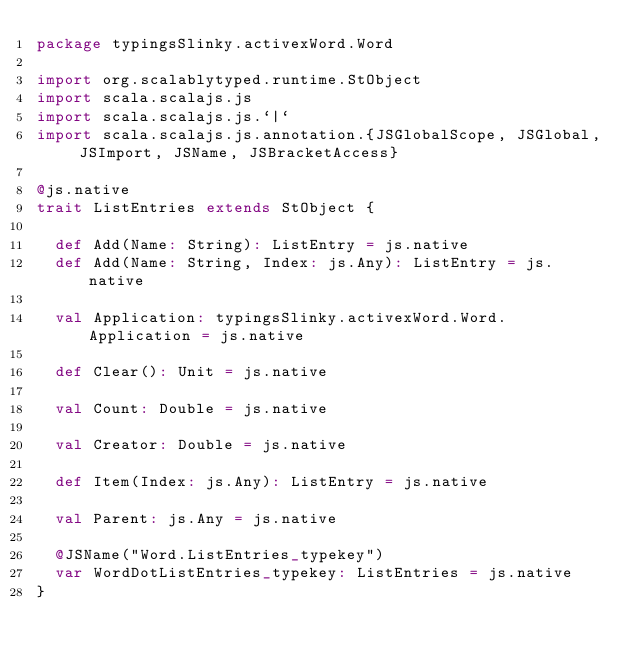Convert code to text. <code><loc_0><loc_0><loc_500><loc_500><_Scala_>package typingsSlinky.activexWord.Word

import org.scalablytyped.runtime.StObject
import scala.scalajs.js
import scala.scalajs.js.`|`
import scala.scalajs.js.annotation.{JSGlobalScope, JSGlobal, JSImport, JSName, JSBracketAccess}

@js.native
trait ListEntries extends StObject {
  
  def Add(Name: String): ListEntry = js.native
  def Add(Name: String, Index: js.Any): ListEntry = js.native
  
  val Application: typingsSlinky.activexWord.Word.Application = js.native
  
  def Clear(): Unit = js.native
  
  val Count: Double = js.native
  
  val Creator: Double = js.native
  
  def Item(Index: js.Any): ListEntry = js.native
  
  val Parent: js.Any = js.native
  
  @JSName("Word.ListEntries_typekey")
  var WordDotListEntries_typekey: ListEntries = js.native
}
</code> 